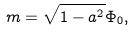Convert formula to latex. <formula><loc_0><loc_0><loc_500><loc_500>m = \sqrt { 1 - a ^ { 2 } } \Phi _ { 0 } ,</formula> 